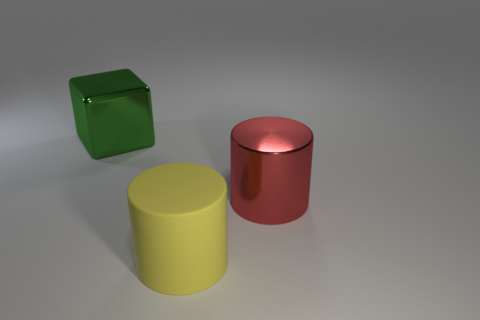There is a shiny cylinder; how many metallic things are to the left of it?
Your response must be concise. 1. The matte object that is the same shape as the large red metal thing is what color?
Keep it short and to the point. Yellow. How many rubber objects are either tiny green balls or green blocks?
Provide a short and direct response. 0. There is a cylinder that is in front of the large metallic object that is in front of the large green shiny thing; is there a red shiny cylinder in front of it?
Offer a very short reply. No. What is the color of the matte cylinder?
Keep it short and to the point. Yellow. Do the big object to the right of the big matte cylinder and the large yellow thing have the same shape?
Ensure brevity in your answer.  Yes. What number of things are either rubber cylinders or large shiny objects that are in front of the big green cube?
Your answer should be compact. 2. Are the large cylinder that is on the left side of the big red shiny thing and the block made of the same material?
Make the answer very short. No. Is there any other thing that is the same size as the green shiny cube?
Your answer should be very brief. Yes. There is a cylinder that is on the right side of the thing in front of the big red thing; what is its material?
Your answer should be very brief. Metal. 